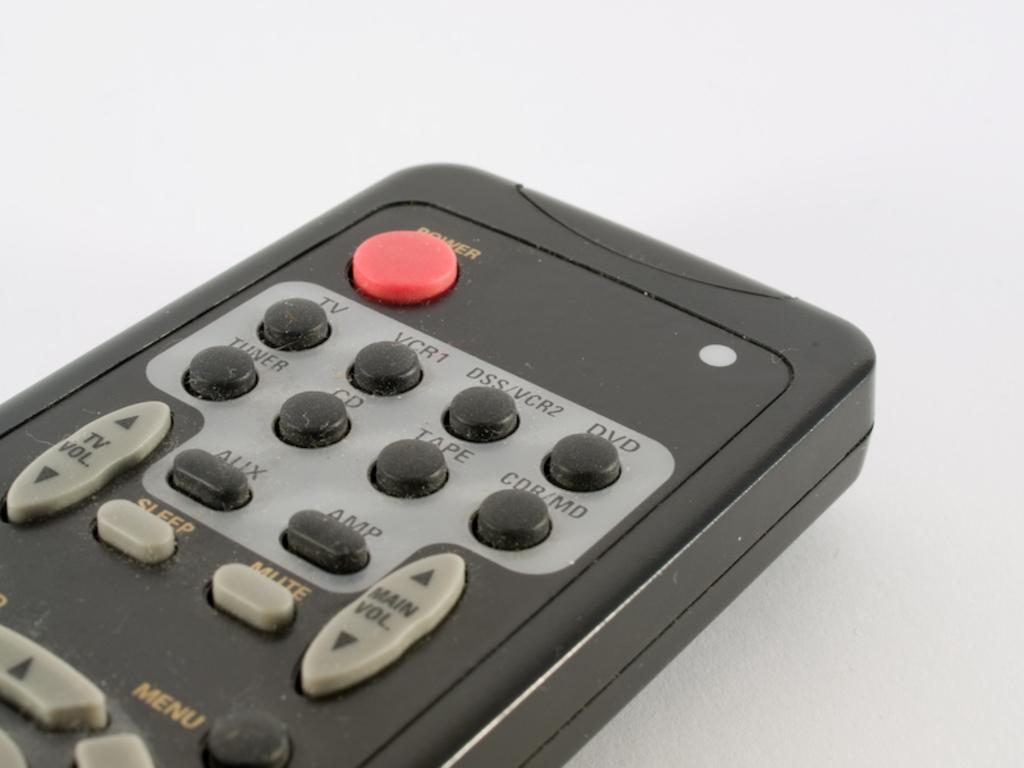Provide a one-sentence caption for the provided image. A close up shot of an old remote's power button, and vcr buttons. 